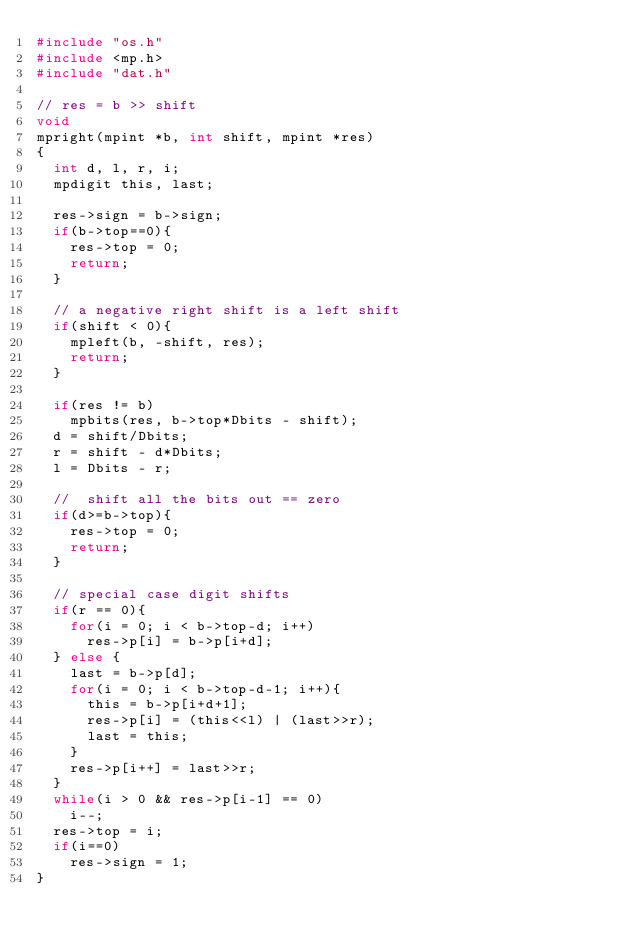<code> <loc_0><loc_0><loc_500><loc_500><_C_>#include "os.h"
#include <mp.h>
#include "dat.h"

// res = b >> shift
void
mpright(mpint *b, int shift, mpint *res)
{
	int d, l, r, i;
	mpdigit this, last;

	res->sign = b->sign;
	if(b->top==0){
		res->top = 0;
		return;
	}

	// a negative right shift is a left shift
	if(shift < 0){
		mpleft(b, -shift, res);
		return;
	}

	if(res != b)
		mpbits(res, b->top*Dbits - shift);
	d = shift/Dbits;
	r = shift - d*Dbits;
	l = Dbits - r;

	//  shift all the bits out == zero
	if(d>=b->top){
		res->top = 0;
		return;
	}

	// special case digit shifts
	if(r == 0){
		for(i = 0; i < b->top-d; i++)
			res->p[i] = b->p[i+d];
	} else {
		last = b->p[d];
		for(i = 0; i < b->top-d-1; i++){
			this = b->p[i+d+1];
			res->p[i] = (this<<l) | (last>>r);
			last = this;
		}
		res->p[i++] = last>>r;
	}
	while(i > 0 && res->p[i-1] == 0)
		i--;
	res->top = i;
	if(i==0)
		res->sign = 1;
}
</code> 